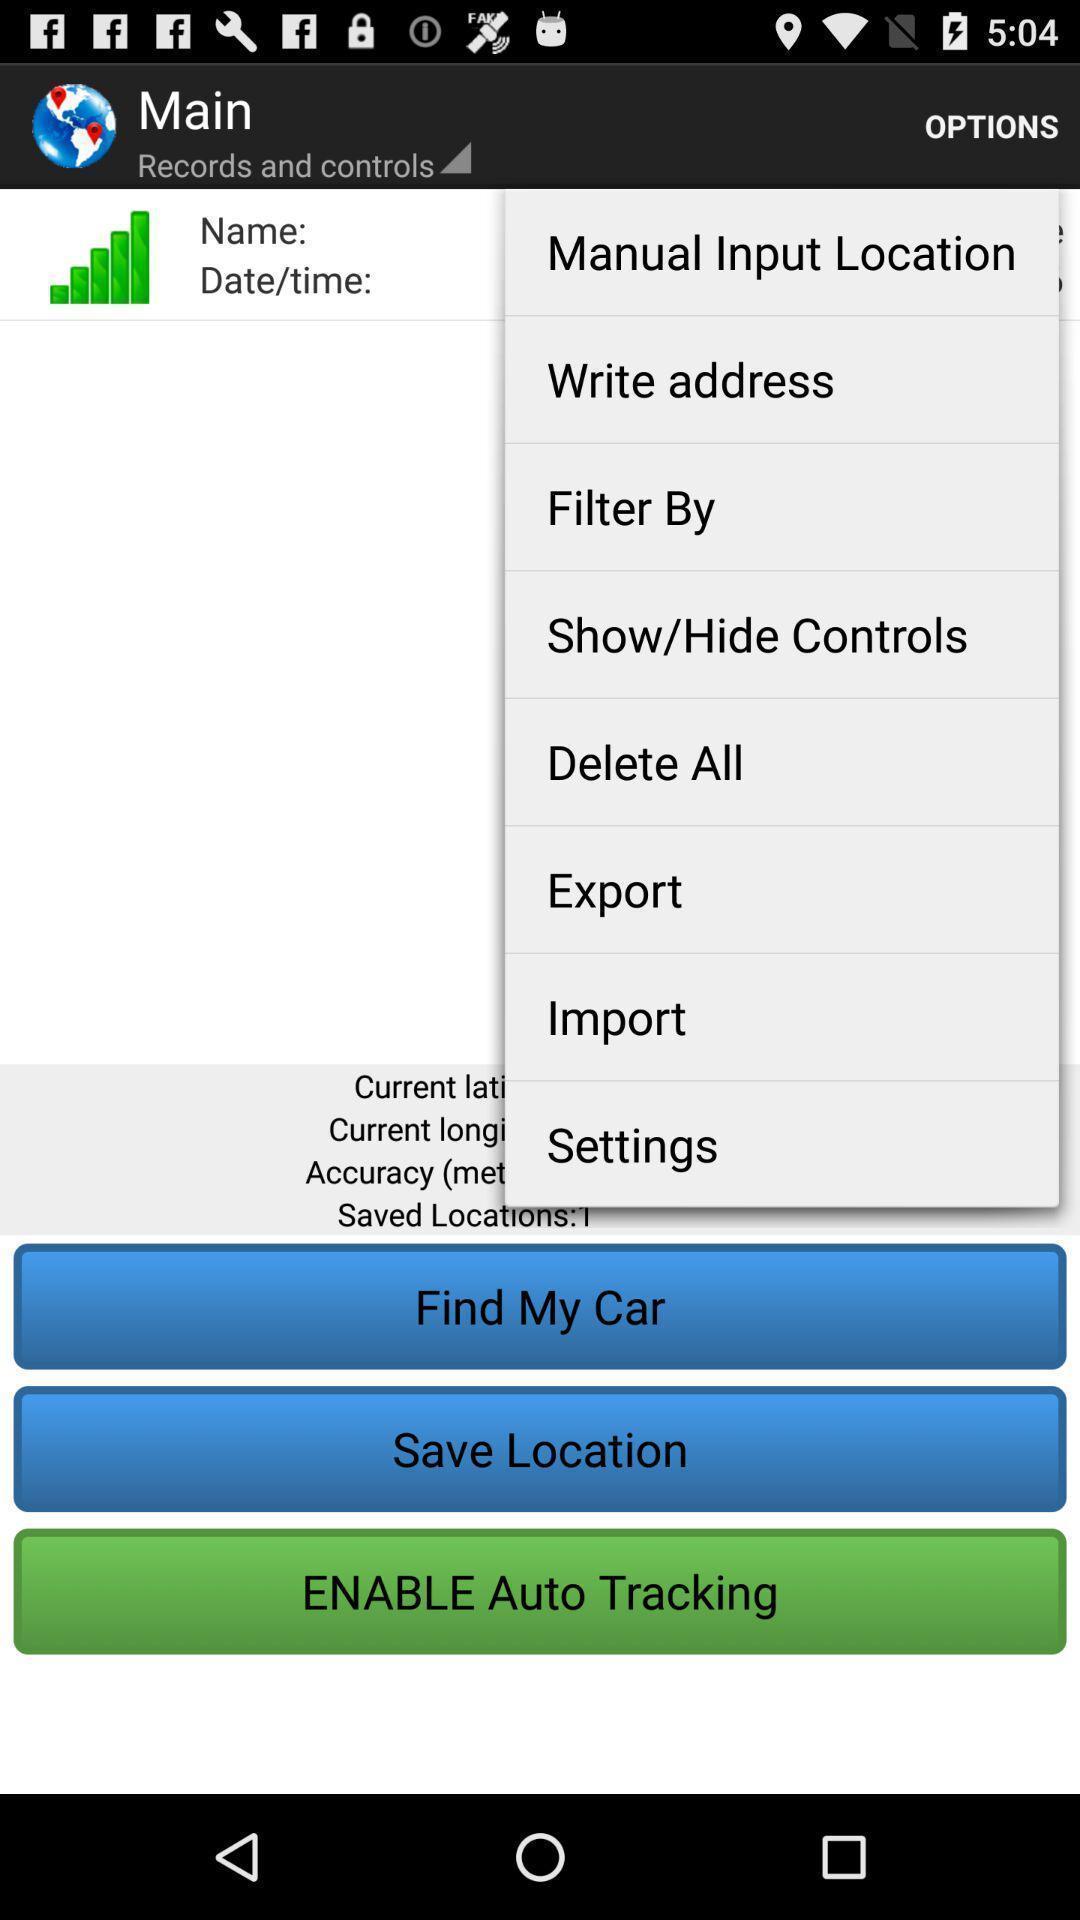Describe the content in this image. Screen displaying the options in a car rental app. 